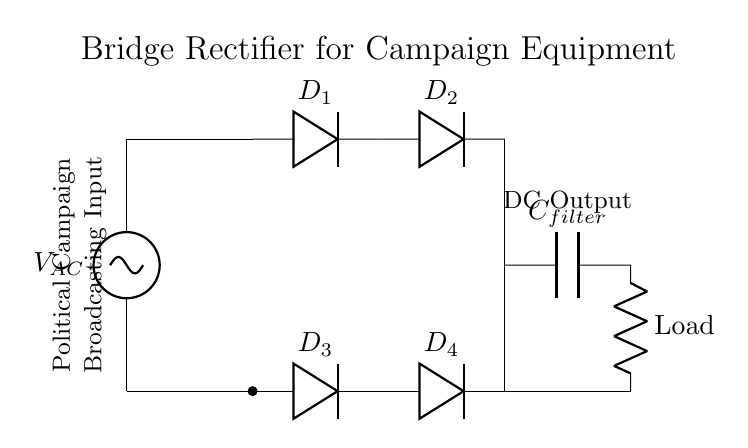What type of rectifier is shown in the circuit? The circuit diagram represents a bridge rectifier, which consists of four diodes arranged in a bridge configuration to convert AC voltage into DC voltage.
Answer: bridge rectifier How many diodes are used in this circuit? There are four diodes labeled D1, D2, D3, and D4 in the circuit, which are responsible for rectifying the AC input.
Answer: four What is the function of the capacitor in this circuit? The capacitor, labeled as C filter, is used for filtering the output voltage, smoothing out the ripples in the DC signal to provide a steady voltage to the load.
Answer: filtering What is the output of the circuit labeled as? The output of the circuit is labeled as "DC Output," indicating that the output signal is in direct current form after rectification.
Answer: DC Output Which component is responsible for converting AC to DC in this circuit? The four diodes (D1, D2, D3, D4) in the bridge rectifier configuration are responsible for converting the incoming AC voltage to DC voltage.
Answer: diodes What would happen if one of the diodes failed? If one of the diodes failed, the bridge rectifier would no longer function properly and either provide no output voltage or produce a significantly reduced or unidirectional output, affecting the performance of the broadcasting equipment.
Answer: reduced output 